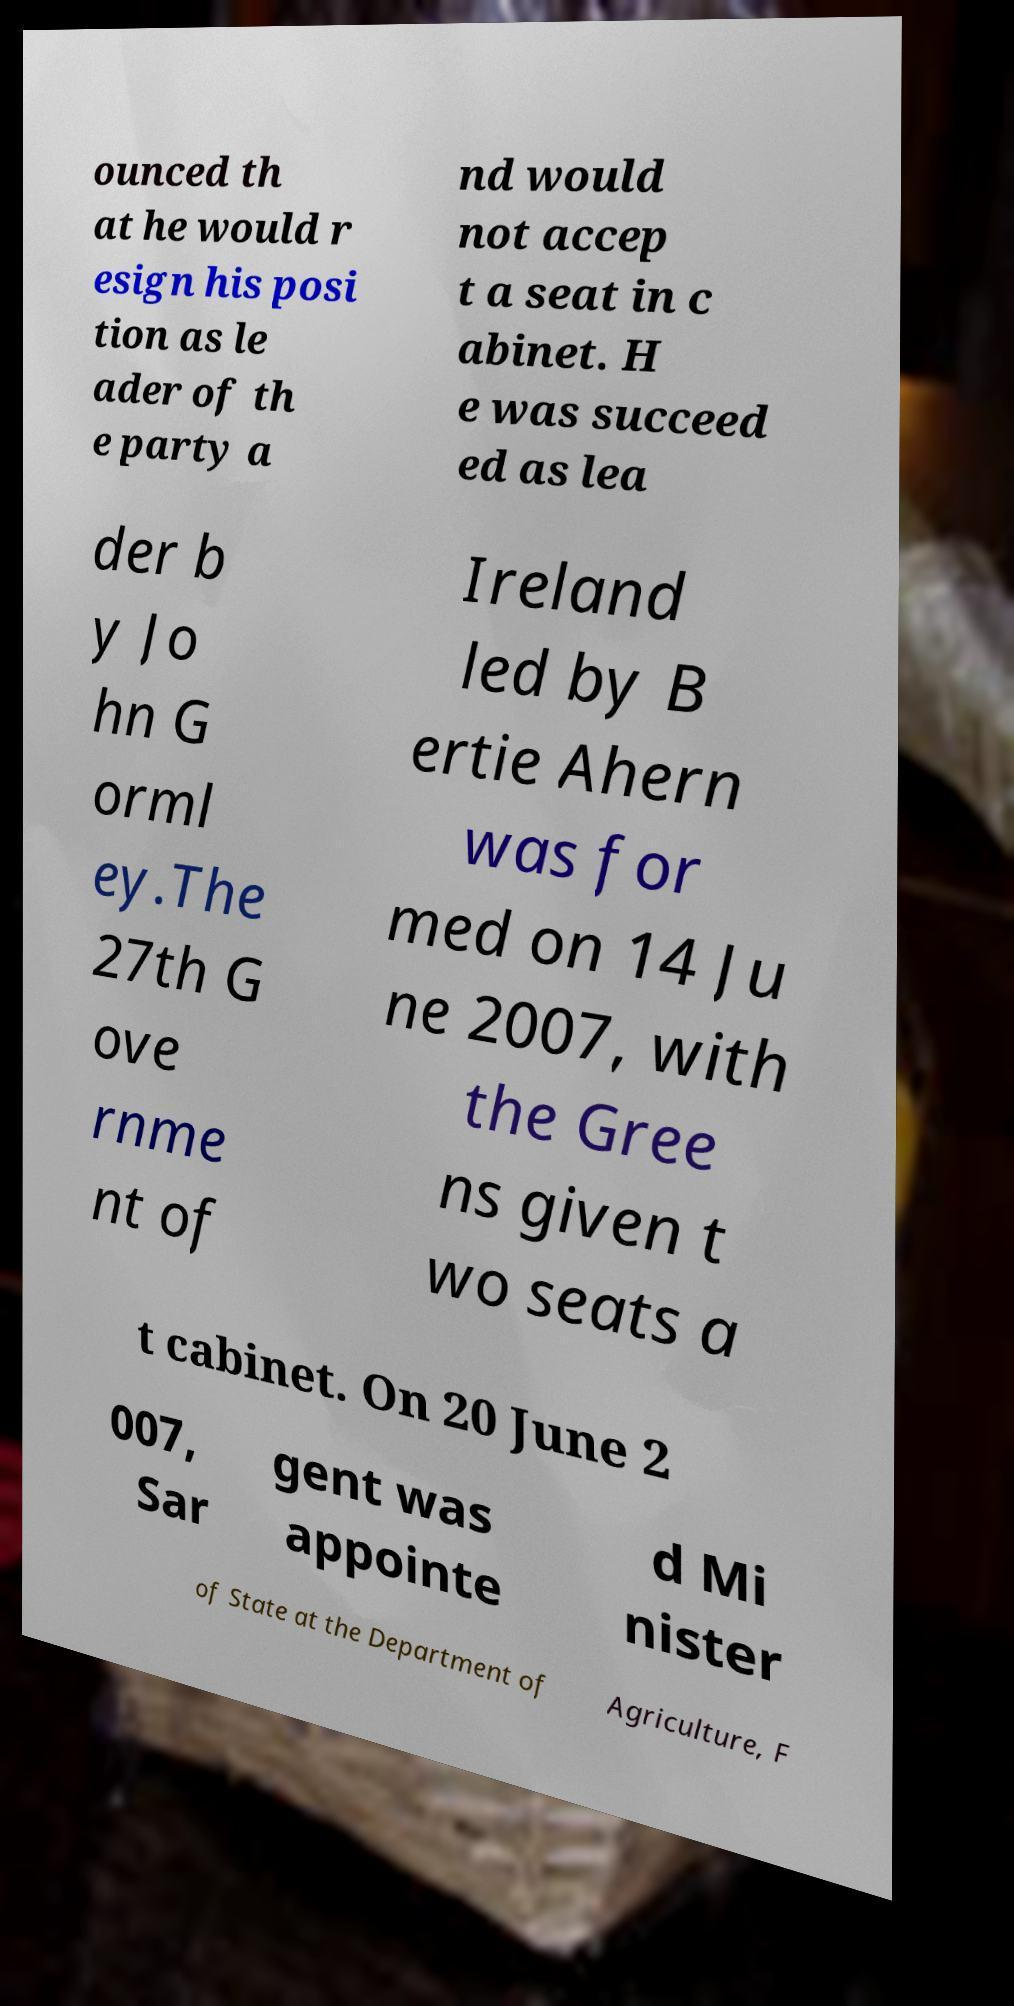Can you read and provide the text displayed in the image?This photo seems to have some interesting text. Can you extract and type it out for me? ounced th at he would r esign his posi tion as le ader of th e party a nd would not accep t a seat in c abinet. H e was succeed ed as lea der b y Jo hn G orml ey.The 27th G ove rnme nt of Ireland led by B ertie Ahern was for med on 14 Ju ne 2007, with the Gree ns given t wo seats a t cabinet. On 20 June 2 007, Sar gent was appointe d Mi nister of State at the Department of Agriculture, F 